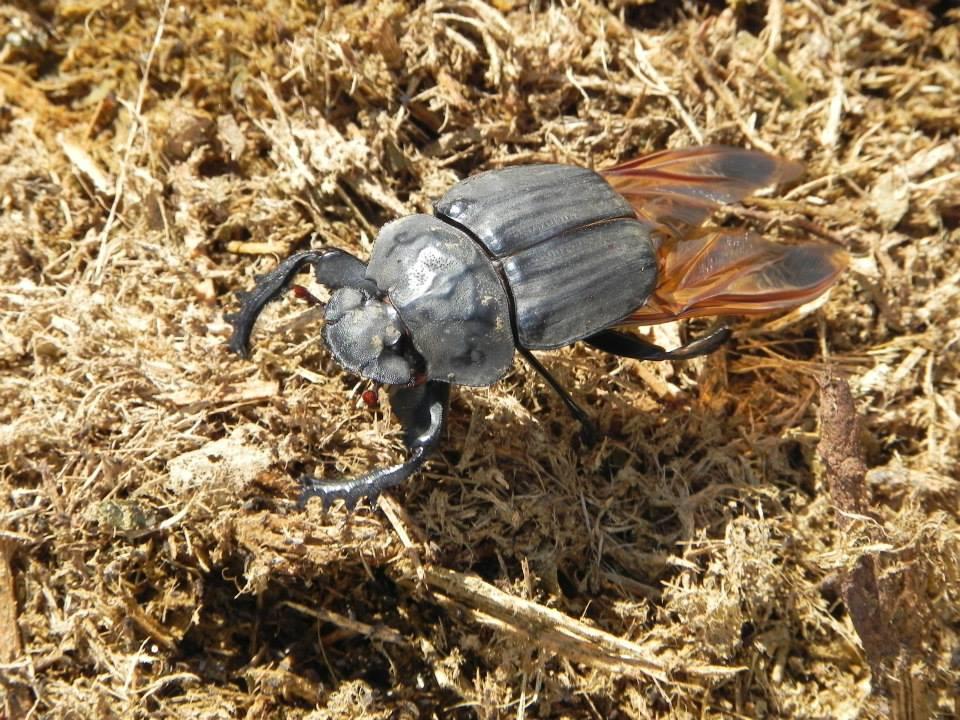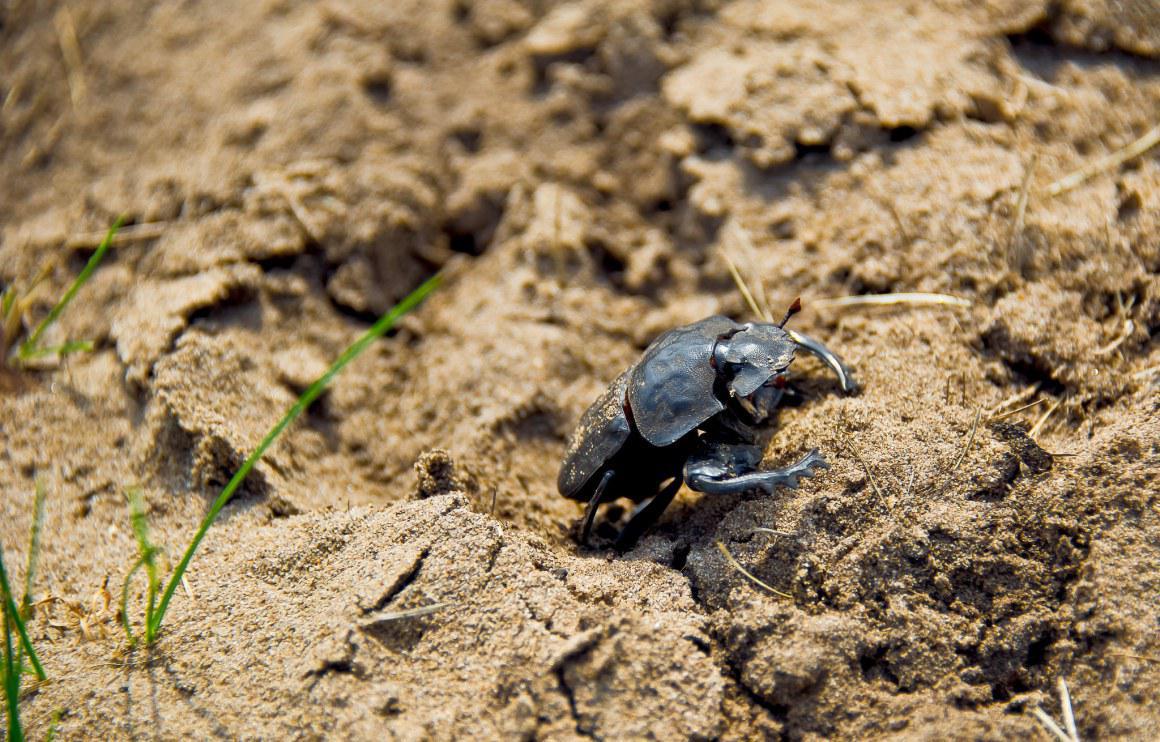The first image is the image on the left, the second image is the image on the right. Examine the images to the left and right. Is the description "Two beetles crawl across the ground." accurate? Answer yes or no. Yes. The first image is the image on the left, the second image is the image on the right. Examine the images to the left and right. Is the description "An image shows one beetle in contact with one round dung ball." accurate? Answer yes or no. No. 